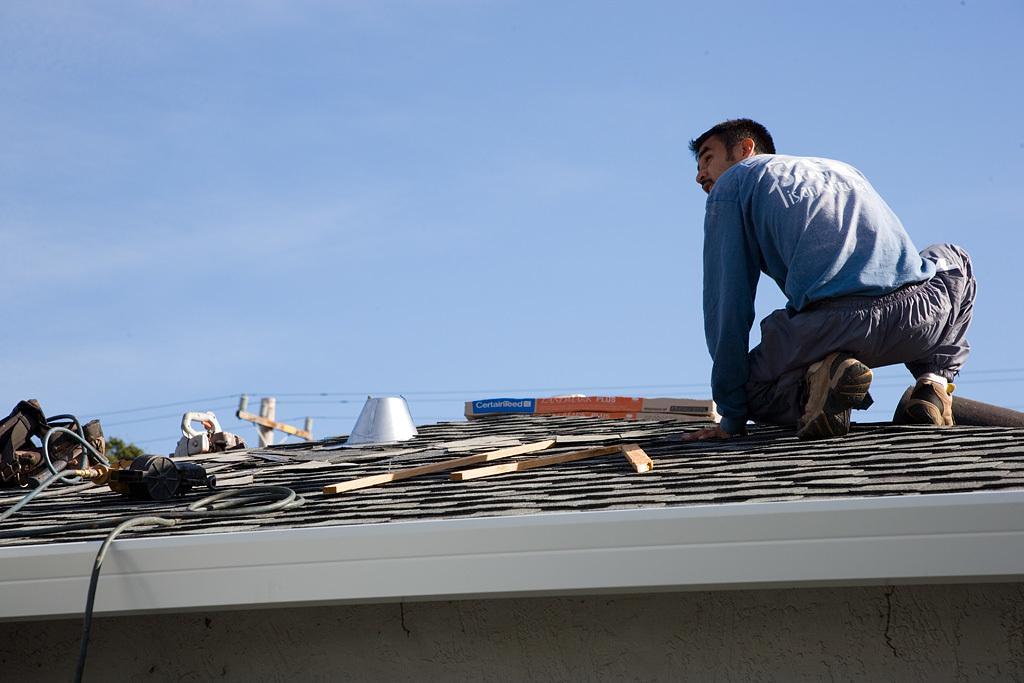In one or two sentences, can you explain what this image depicts? In this image we can see a rooftop. On that there is a person, wooden pieces, wires and some other objects. In the back there is an electric pole with wires. Also there is sky with clouds. 